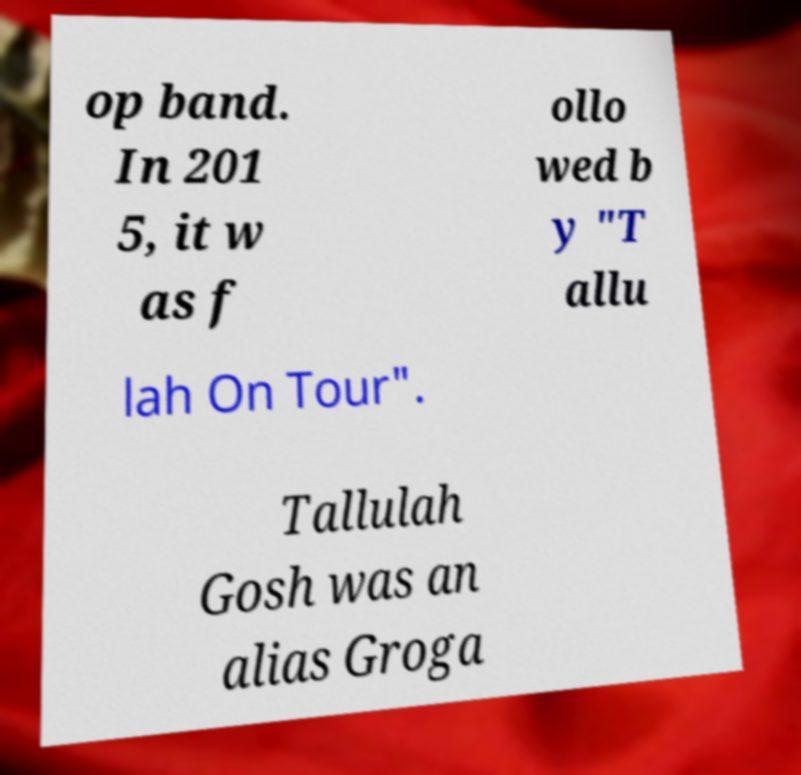Can you read and provide the text displayed in the image?This photo seems to have some interesting text. Can you extract and type it out for me? op band. In 201 5, it w as f ollo wed b y "T allu lah On Tour". Tallulah Gosh was an alias Groga 